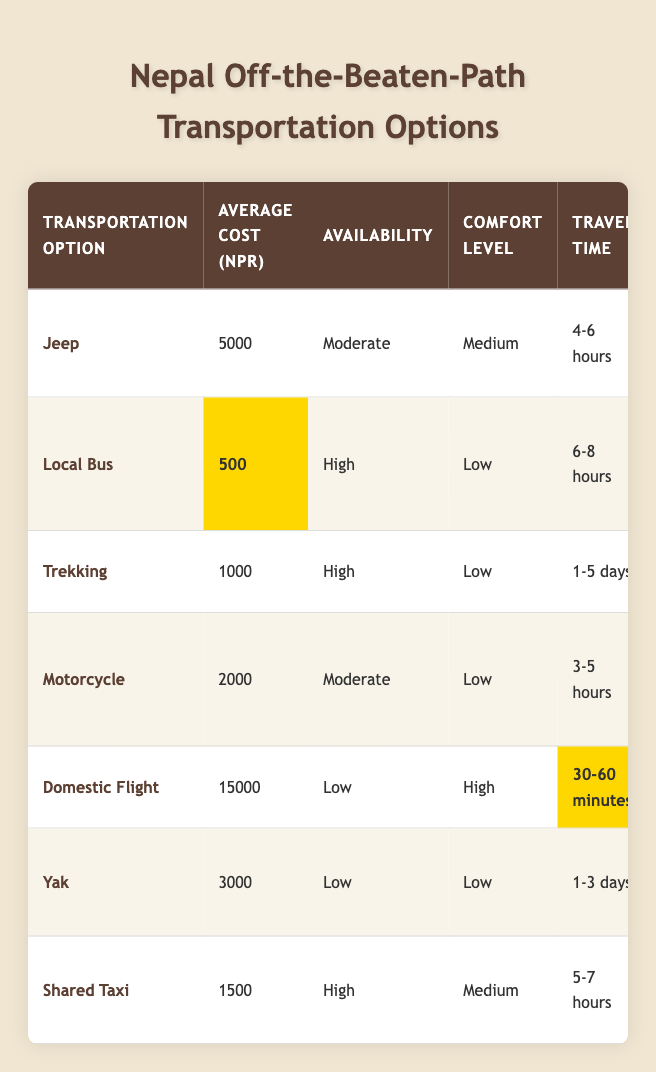What is the average cost of using a local bus? The average cost for a local bus is listed in the table as 500 NPR.
Answer: 500 NPR Which transportation option has the highest average cost? The domestic flight has the highest average cost listed at 15000 NPR.
Answer: Domestic Flight Is trekking a suitable option for all terrains? Yes, according to the table, trekking is suitable for all terrains as mentioned.
Answer: Yes How long does it take on average to travel by jeep? The travel time for a jeep is listed as 4-6 hours, which is the range given for this transportation option.
Answer: 4-6 hours What is the combined maximum capacity of a shared taxi and a local bus? The maximum capacity of a shared taxi is 4, and a local bus is 30. Adding these gives us 4 + 30 = 34.
Answer: 34 Which option has the lowest environmental impact? The yak has the lowest environmental impact listed as very low in the table.
Answer: Yak Can you confirm if a motorcycle can fit more than two people? No, the maximum capacity of a motorcycle is 2, so it cannot fit more than two people.
Answer: No What is the average travel time for all transportation options considered together? To find the average travel time, we consider the time ranges: Jeep (5 hours average), local bus (7 hours), trekking (3 days or 72 hours average for calculation), motorcycle (4 hours average), domestic flight (45 minutes or 0.75 hours), yak (2 days or 48 hours). Combining these values (5 + 7 + 72 + 4 + 0.75 + 48 = 136.75), and dividing by 6 gives approximately 22.79 hours.
Answer: Approximately 22.79 hours Which option offers the highest local experience? Trekking and yak provide the highest local experience, as both options are rated as very high in this category.
Answer: Trekking and Yak 